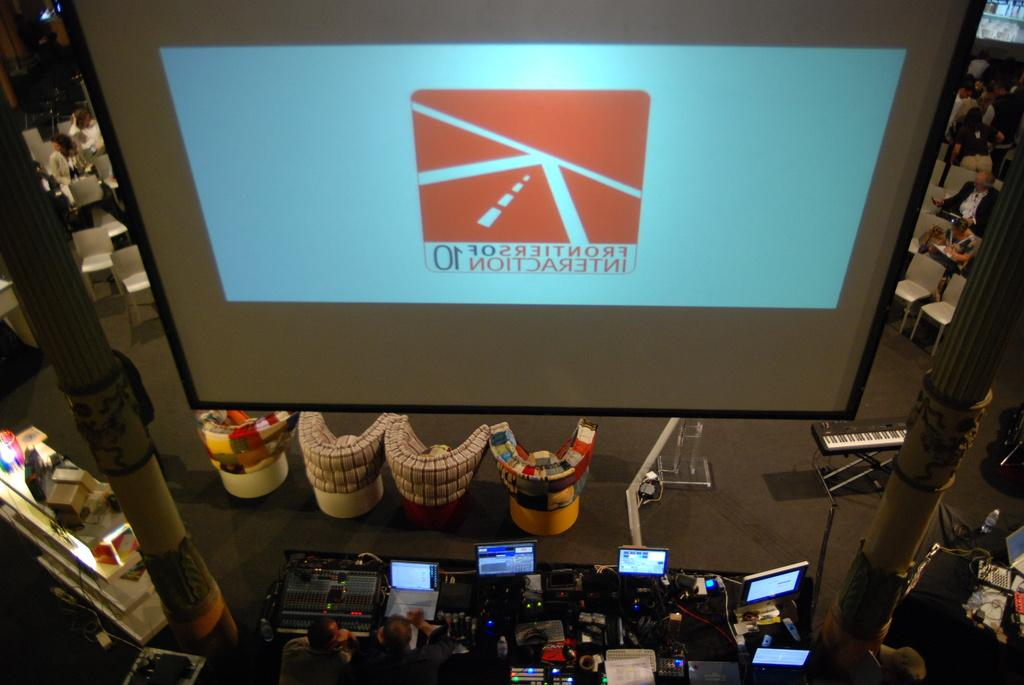<image>
Describe the image concisely. A large screen has Frontiers of Interaction 10 written on it backwards. 